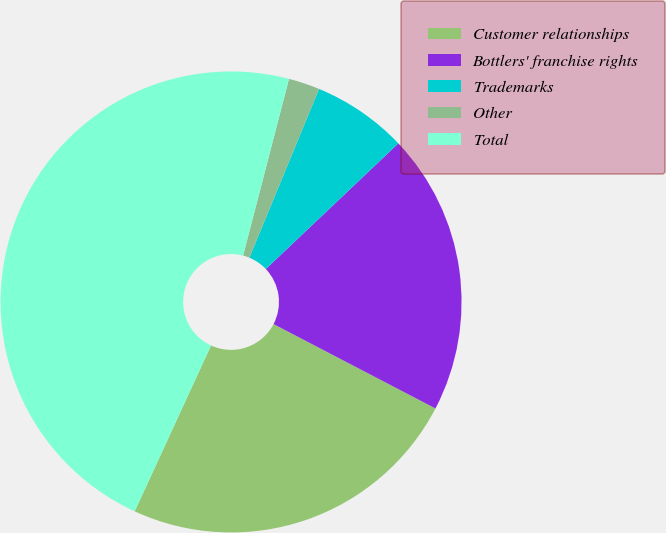Convert chart to OTSL. <chart><loc_0><loc_0><loc_500><loc_500><pie_chart><fcel>Customer relationships<fcel>Bottlers' franchise rights<fcel>Trademarks<fcel>Other<fcel>Total<nl><fcel>24.22%<fcel>19.72%<fcel>6.69%<fcel>2.19%<fcel>47.18%<nl></chart> 